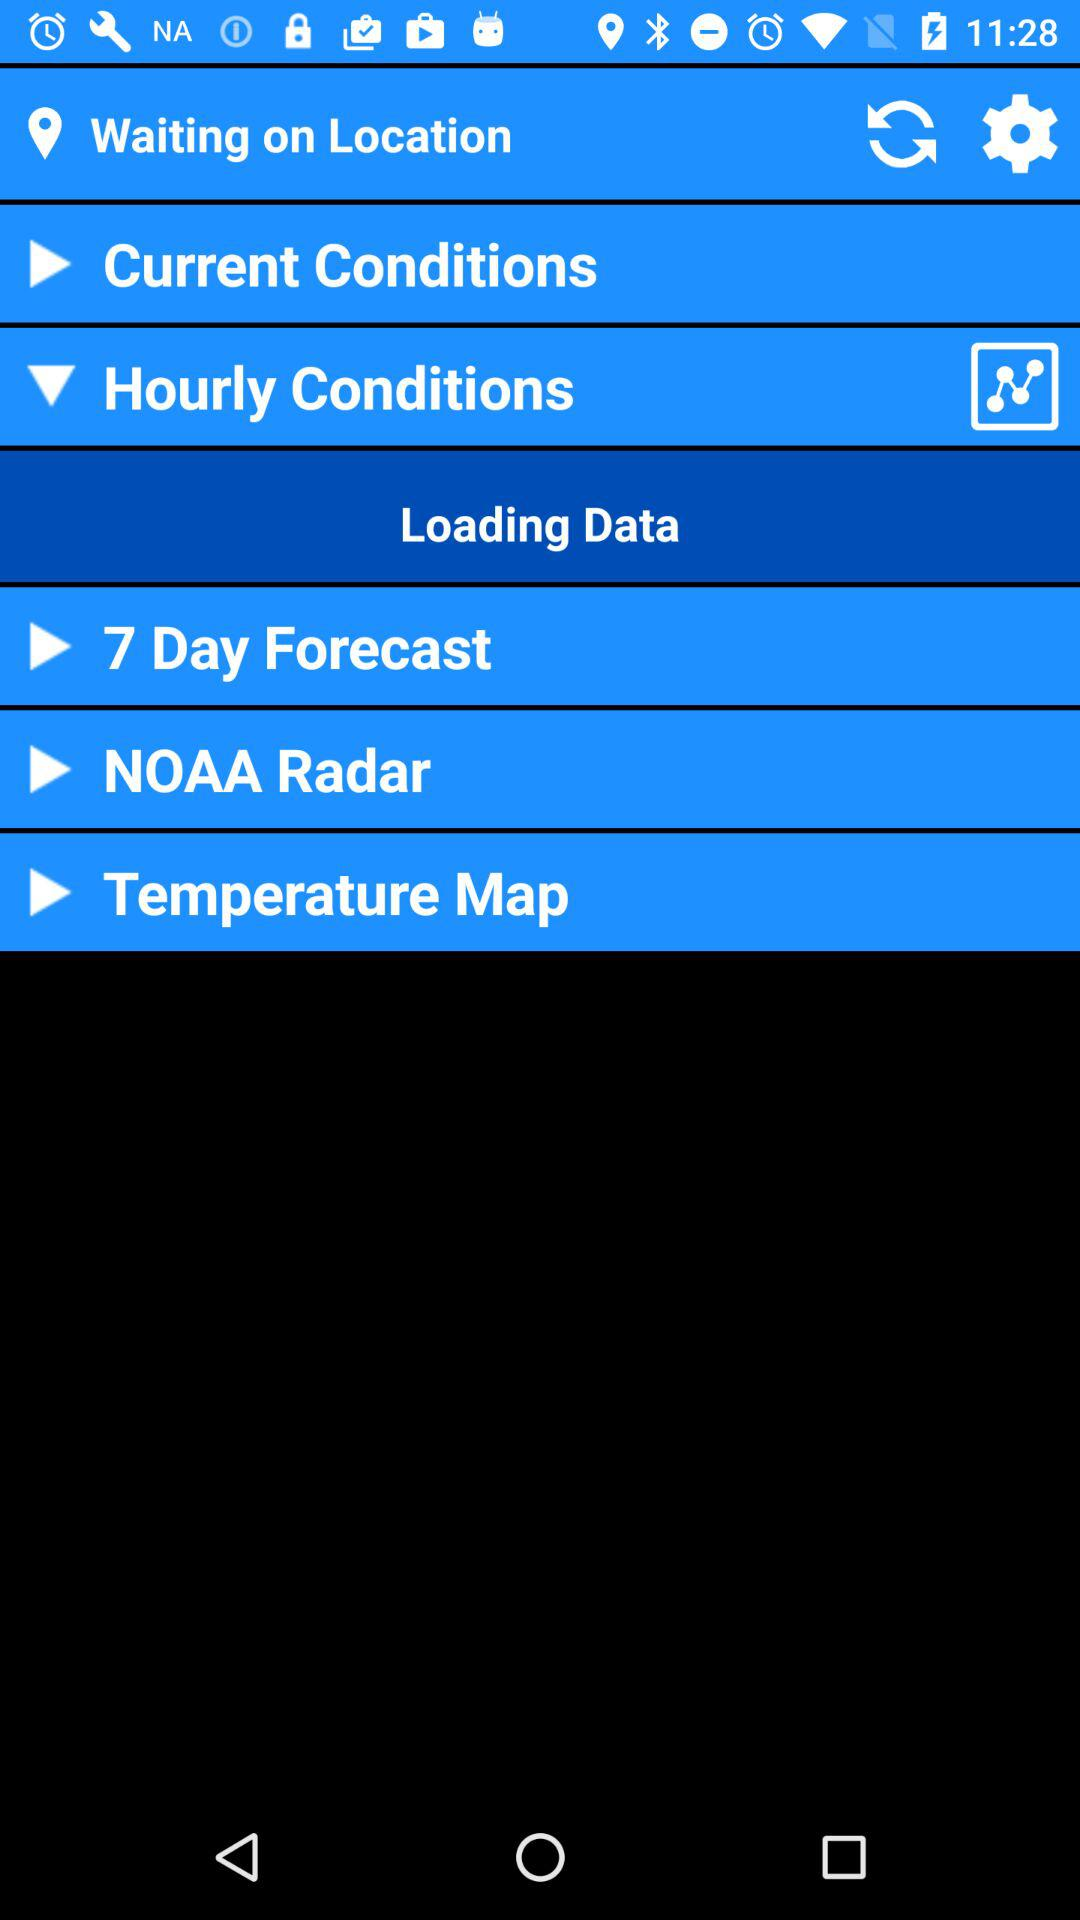How many days is the forecast for? The forecast is for 7 days. 